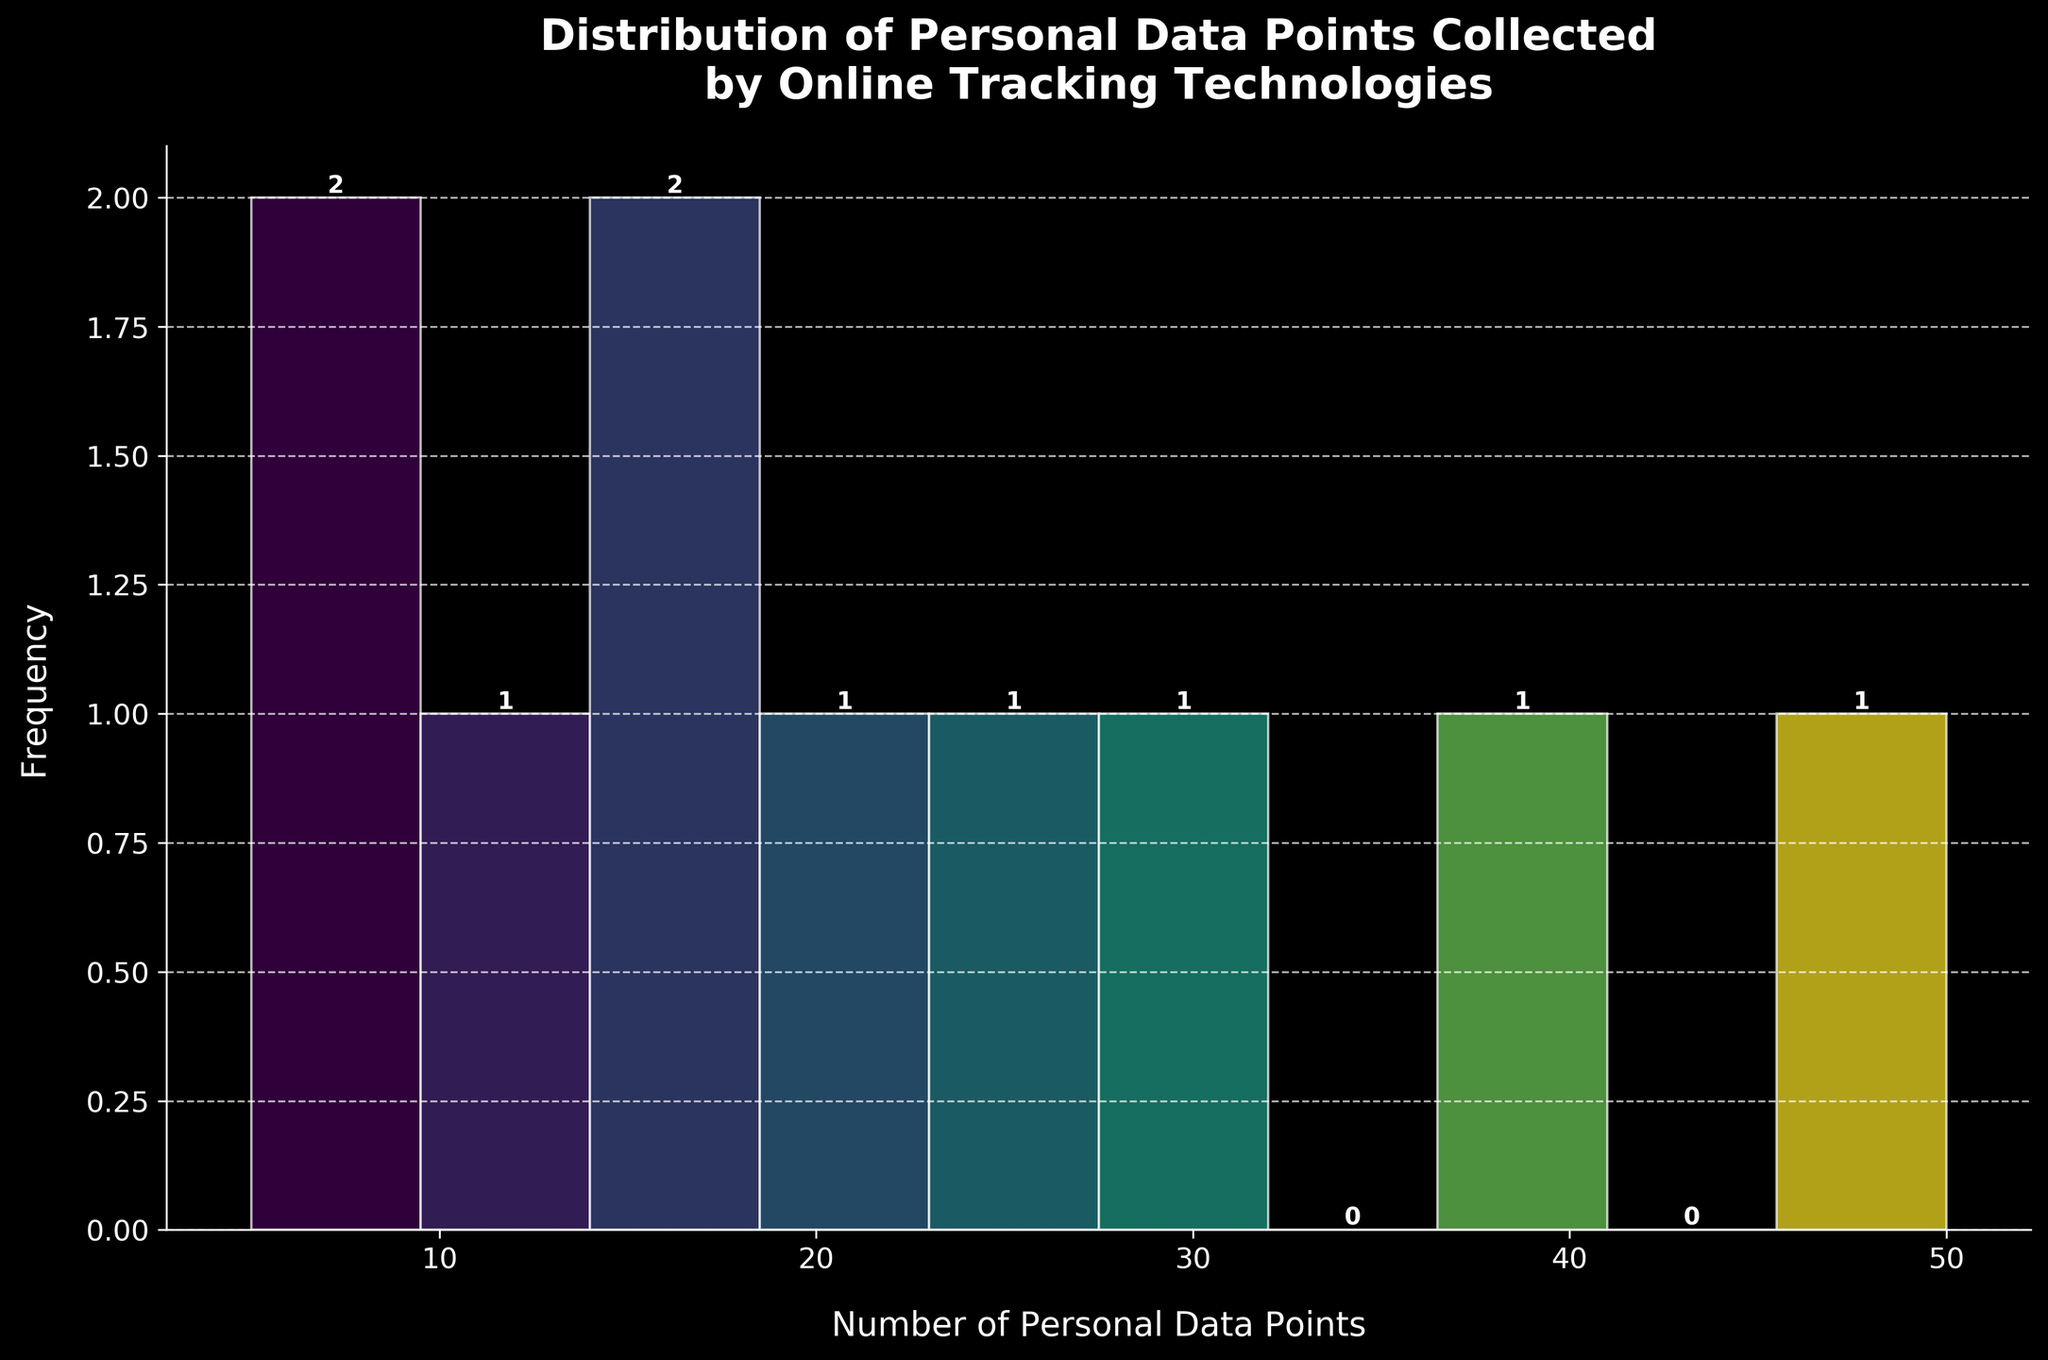What is the title of the histogram? The title of the histogram is the text located at the top of the figure, usually describing what the histogram is about. In this case, it says "Distribution of Personal Data Points Collected by Online Tracking Technologies."
Answer: Distribution of Personal Data Points Collected by Online Tracking Technologies What is the range of the x-axis? The x-axis represents the number of personal data points collected, which ranges from the lowest to the highest value shown in the data. It starts at 0 and ends at 50.
Answer: 0 to 50 Which interval has the highest frequency? Identify the interval with the highest bars in the histogram. The tallest bar represents the interval with the highest frequency. Based on the histogram, the interval 40-50 has the highest frequency.
Answer: 40-50 How many intervals have zero frequency? Count the intervals in the histogram where the frequency is zero. The bars in these intervals would be missing or have no height. Based on the histogram, there are two intervals with zero frequency, which are 0-10 and 30-40.
Answer: 2 What is the frequency of the interval 10-20? Look at the bar corresponding to the interval 10-20 and read off the frequency value from the y-axis. This bar represents the number of times technologies collected between 10 and 20 data points.
Answer: 3 Are there more technologies collecting less than 20 data points or more than 30 data points? Count the number of technologies collecting less than 20 data points (sum of frequencies for intervals 0-10 and 10-20) and those collecting more than 30 data points (sum of frequencies for intervals 30-40 and 40-50). There are fewer bars for below 20 data points (3) compared to above 30 data points (3+2). Since 3 intervals contribute as opposed to 2, more are collected above 30 data points.
Answer: More than 30 What is the total number of tracking technologies represented in the histogram? To find this, sum up the frequencies of all the bars in the histogram. These represent different tracking technologies.
Answer: 10 What is the approximate average number of personal data points collected by the technologies? Calculate the sum of all data points collected and divide by the number of technologies. Sum of data points: (15+30+8+25+40+20+50+12+5+18) = 223. Dividing by the number of technologies (10), the average is approximately 22.3.
Answer: 22.3 Does any technology collect exactly 50 data points? Look for the bar corresponding to the exact number of 50 data points on the x-axis. From the data, we know Session Replay Tools collect exactly 50 data points.
Answer: Yes Which interval has the second highest frequency, and what is its value? Identify the bar with the second highest height after the tallest one (40-50). The interval with the second highest frequency is 30-40, with a frequency value of 1.
Answer: 30-40, 1 